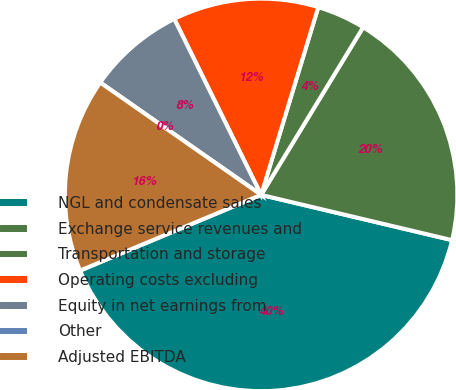Convert chart to OTSL. <chart><loc_0><loc_0><loc_500><loc_500><pie_chart><fcel>NGL and condensate sales<fcel>Exchange service revenues and<fcel>Transportation and storage<fcel>Operating costs excluding<fcel>Equity in net earnings from<fcel>Other<fcel>Adjusted EBITDA<nl><fcel>39.99%<fcel>20.0%<fcel>4.0%<fcel>12.0%<fcel>8.0%<fcel>0.0%<fcel>16.0%<nl></chart> 